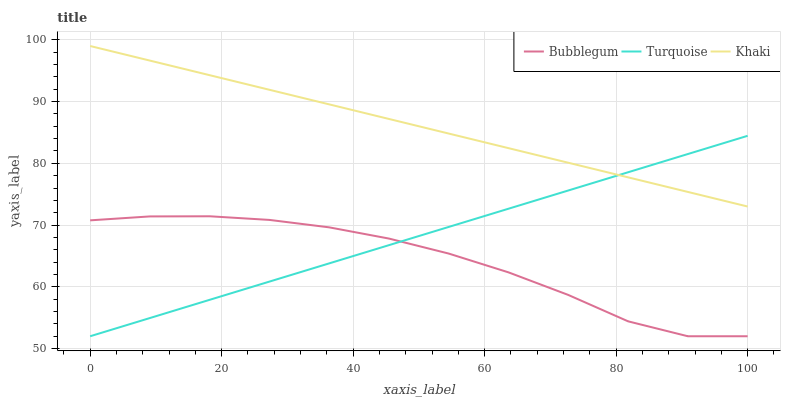Does Bubblegum have the minimum area under the curve?
Answer yes or no. Yes. Does Khaki have the maximum area under the curve?
Answer yes or no. Yes. Does Khaki have the minimum area under the curve?
Answer yes or no. No. Does Bubblegum have the maximum area under the curve?
Answer yes or no. No. Is Turquoise the smoothest?
Answer yes or no. Yes. Is Bubblegum the roughest?
Answer yes or no. Yes. Is Khaki the smoothest?
Answer yes or no. No. Is Khaki the roughest?
Answer yes or no. No. Does Turquoise have the lowest value?
Answer yes or no. Yes. Does Khaki have the lowest value?
Answer yes or no. No. Does Khaki have the highest value?
Answer yes or no. Yes. Does Bubblegum have the highest value?
Answer yes or no. No. Is Bubblegum less than Khaki?
Answer yes or no. Yes. Is Khaki greater than Bubblegum?
Answer yes or no. Yes. Does Turquoise intersect Khaki?
Answer yes or no. Yes. Is Turquoise less than Khaki?
Answer yes or no. No. Is Turquoise greater than Khaki?
Answer yes or no. No. Does Bubblegum intersect Khaki?
Answer yes or no. No. 